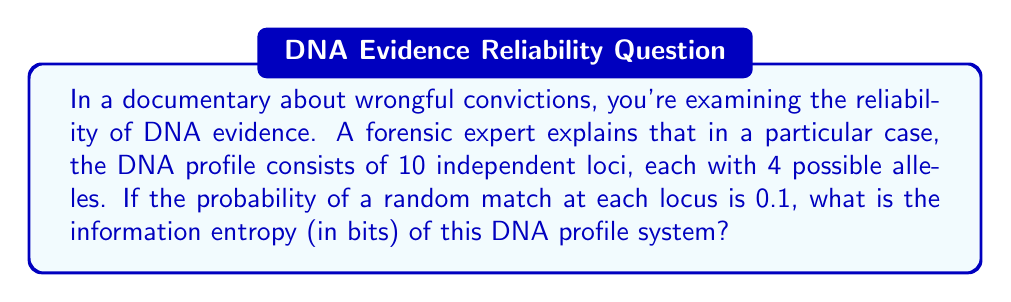Solve this math problem. To solve this problem, we need to understand and apply the concept of information entropy from information theory. Let's break it down step-by-step:

1) First, recall the formula for information entropy:

   $$H = -\sum_{i=1}^n p_i \log_2(p_i)$$

   where $p_i$ is the probability of each possible outcome.

2) In this case, we have 10 independent loci, each with a probability of 0.1 for a match. The probability of a full match across all 10 loci is:

   $$p_{match} = 0.1^{10} = 10^{-10}$$

3) The probability of not matching is therefore:

   $$p_{no match} = 1 - 10^{-10}$$

4) Now we can apply the entropy formula:

   $$H = -(p_{match} \log_2(p_{match}) + p_{no match} \log_2(p_{no match}))$$

5) Let's calculate each term:

   $$p_{match} \log_2(p_{match}) = 10^{-10} \log_2(10^{-10}) = 10^{-10} \cdot (-33.219) = -3.3219 \times 10^{-9}$$

   $$p_{no match} \log_2(p_{no match}) \approx 1 \cdot \log_2(1) = 0$$

   (The approximation is valid because $1 - 10^{-10}$ is extremely close to 1)

6) Summing these up:

   $$H = -(-3.3219 \times 10^{-9} + 0) = 3.3219 \times 10^{-9}$$

7) This result is in bits, as we used $\log_2$ in our calculations.
Answer: The information entropy of the DNA profile system is approximately $3.3219 \times 10^{-9}$ bits. 